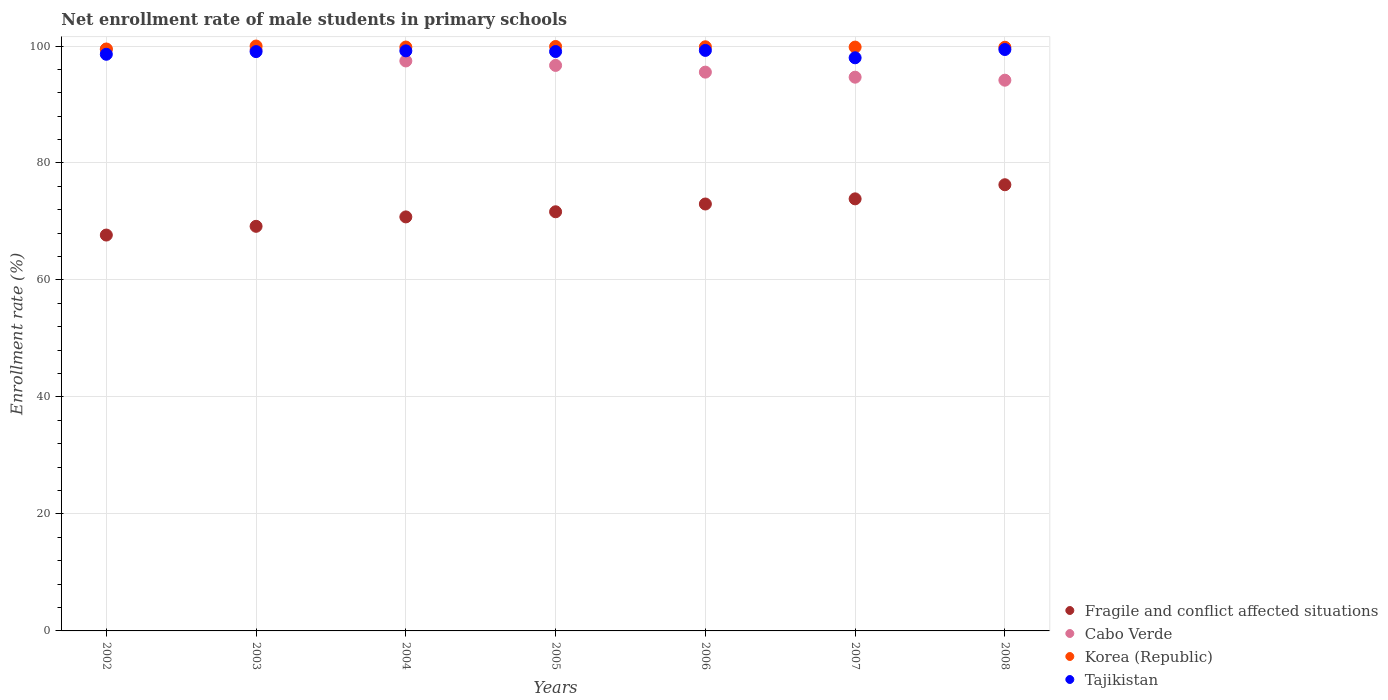How many different coloured dotlines are there?
Offer a very short reply. 4. Is the number of dotlines equal to the number of legend labels?
Your answer should be compact. Yes. What is the net enrollment rate of male students in primary schools in Korea (Republic) in 2008?
Provide a succinct answer. 99.78. Across all years, what is the maximum net enrollment rate of male students in primary schools in Cabo Verde?
Offer a terse response. 99.43. Across all years, what is the minimum net enrollment rate of male students in primary schools in Korea (Republic)?
Your answer should be very brief. 99.49. What is the total net enrollment rate of male students in primary schools in Fragile and conflict affected situations in the graph?
Your answer should be compact. 502.43. What is the difference between the net enrollment rate of male students in primary schools in Tajikistan in 2003 and that in 2005?
Keep it short and to the point. -0.01. What is the difference between the net enrollment rate of male students in primary schools in Korea (Republic) in 2008 and the net enrollment rate of male students in primary schools in Cabo Verde in 2007?
Keep it short and to the point. 5.11. What is the average net enrollment rate of male students in primary schools in Fragile and conflict affected situations per year?
Keep it short and to the point. 71.78. In the year 2005, what is the difference between the net enrollment rate of male students in primary schools in Korea (Republic) and net enrollment rate of male students in primary schools in Cabo Verde?
Your answer should be very brief. 3.24. In how many years, is the net enrollment rate of male students in primary schools in Korea (Republic) greater than 84 %?
Give a very brief answer. 7. What is the ratio of the net enrollment rate of male students in primary schools in Fragile and conflict affected situations in 2003 to that in 2005?
Offer a very short reply. 0.97. Is the difference between the net enrollment rate of male students in primary schools in Korea (Republic) in 2002 and 2006 greater than the difference between the net enrollment rate of male students in primary schools in Cabo Verde in 2002 and 2006?
Your answer should be compact. No. What is the difference between the highest and the second highest net enrollment rate of male students in primary schools in Fragile and conflict affected situations?
Your response must be concise. 2.41. What is the difference between the highest and the lowest net enrollment rate of male students in primary schools in Tajikistan?
Your answer should be very brief. 1.41. In how many years, is the net enrollment rate of male students in primary schools in Tajikistan greater than the average net enrollment rate of male students in primary schools in Tajikistan taken over all years?
Offer a terse response. 5. Is the sum of the net enrollment rate of male students in primary schools in Tajikistan in 2005 and 2006 greater than the maximum net enrollment rate of male students in primary schools in Korea (Republic) across all years?
Your answer should be very brief. Yes. Is it the case that in every year, the sum of the net enrollment rate of male students in primary schools in Cabo Verde and net enrollment rate of male students in primary schools in Korea (Republic)  is greater than the sum of net enrollment rate of male students in primary schools in Tajikistan and net enrollment rate of male students in primary schools in Fragile and conflict affected situations?
Ensure brevity in your answer.  No. Is the net enrollment rate of male students in primary schools in Fragile and conflict affected situations strictly greater than the net enrollment rate of male students in primary schools in Korea (Republic) over the years?
Provide a succinct answer. No. Is the net enrollment rate of male students in primary schools in Fragile and conflict affected situations strictly less than the net enrollment rate of male students in primary schools in Cabo Verde over the years?
Your response must be concise. Yes. How many dotlines are there?
Make the answer very short. 4. What is the difference between two consecutive major ticks on the Y-axis?
Give a very brief answer. 20. Are the values on the major ticks of Y-axis written in scientific E-notation?
Offer a very short reply. No. Does the graph contain grids?
Your answer should be compact. Yes. Where does the legend appear in the graph?
Provide a short and direct response. Bottom right. How many legend labels are there?
Offer a very short reply. 4. How are the legend labels stacked?
Keep it short and to the point. Vertical. What is the title of the graph?
Your answer should be compact. Net enrollment rate of male students in primary schools. Does "India" appear as one of the legend labels in the graph?
Offer a terse response. No. What is the label or title of the Y-axis?
Offer a very short reply. Enrollment rate (%). What is the Enrollment rate (%) of Fragile and conflict affected situations in 2002?
Offer a very short reply. 67.68. What is the Enrollment rate (%) of Cabo Verde in 2002?
Give a very brief answer. 99.43. What is the Enrollment rate (%) of Korea (Republic) in 2002?
Your response must be concise. 99.49. What is the Enrollment rate (%) of Tajikistan in 2002?
Ensure brevity in your answer.  98.59. What is the Enrollment rate (%) in Fragile and conflict affected situations in 2003?
Your answer should be very brief. 69.17. What is the Enrollment rate (%) of Cabo Verde in 2003?
Provide a succinct answer. 99.38. What is the Enrollment rate (%) of Korea (Republic) in 2003?
Provide a succinct answer. 100. What is the Enrollment rate (%) in Tajikistan in 2003?
Ensure brevity in your answer.  99.04. What is the Enrollment rate (%) in Fragile and conflict affected situations in 2004?
Your answer should be very brief. 70.78. What is the Enrollment rate (%) in Cabo Verde in 2004?
Keep it short and to the point. 97.44. What is the Enrollment rate (%) in Korea (Republic) in 2004?
Offer a very short reply. 99.82. What is the Enrollment rate (%) of Tajikistan in 2004?
Your answer should be very brief. 99.17. What is the Enrollment rate (%) in Fragile and conflict affected situations in 2005?
Offer a very short reply. 71.66. What is the Enrollment rate (%) of Cabo Verde in 2005?
Provide a short and direct response. 96.68. What is the Enrollment rate (%) of Korea (Republic) in 2005?
Make the answer very short. 99.92. What is the Enrollment rate (%) of Tajikistan in 2005?
Your response must be concise. 99.05. What is the Enrollment rate (%) of Fragile and conflict affected situations in 2006?
Offer a terse response. 72.99. What is the Enrollment rate (%) of Cabo Verde in 2006?
Your answer should be very brief. 95.53. What is the Enrollment rate (%) of Korea (Republic) in 2006?
Ensure brevity in your answer.  99.87. What is the Enrollment rate (%) in Tajikistan in 2006?
Make the answer very short. 99.25. What is the Enrollment rate (%) of Fragile and conflict affected situations in 2007?
Your response must be concise. 73.87. What is the Enrollment rate (%) in Cabo Verde in 2007?
Your answer should be very brief. 94.67. What is the Enrollment rate (%) in Korea (Republic) in 2007?
Offer a very short reply. 99.81. What is the Enrollment rate (%) of Tajikistan in 2007?
Give a very brief answer. 97.99. What is the Enrollment rate (%) of Fragile and conflict affected situations in 2008?
Provide a short and direct response. 76.28. What is the Enrollment rate (%) in Cabo Verde in 2008?
Your answer should be very brief. 94.15. What is the Enrollment rate (%) of Korea (Republic) in 2008?
Make the answer very short. 99.78. What is the Enrollment rate (%) of Tajikistan in 2008?
Your answer should be compact. 99.4. Across all years, what is the maximum Enrollment rate (%) of Fragile and conflict affected situations?
Your answer should be compact. 76.28. Across all years, what is the maximum Enrollment rate (%) in Cabo Verde?
Give a very brief answer. 99.43. Across all years, what is the maximum Enrollment rate (%) of Korea (Republic)?
Keep it short and to the point. 100. Across all years, what is the maximum Enrollment rate (%) in Tajikistan?
Provide a short and direct response. 99.4. Across all years, what is the minimum Enrollment rate (%) of Fragile and conflict affected situations?
Keep it short and to the point. 67.68. Across all years, what is the minimum Enrollment rate (%) of Cabo Verde?
Your response must be concise. 94.15. Across all years, what is the minimum Enrollment rate (%) of Korea (Republic)?
Your answer should be very brief. 99.49. Across all years, what is the minimum Enrollment rate (%) in Tajikistan?
Provide a succinct answer. 97.99. What is the total Enrollment rate (%) of Fragile and conflict affected situations in the graph?
Ensure brevity in your answer.  502.43. What is the total Enrollment rate (%) of Cabo Verde in the graph?
Keep it short and to the point. 677.29. What is the total Enrollment rate (%) of Korea (Republic) in the graph?
Your response must be concise. 698.69. What is the total Enrollment rate (%) in Tajikistan in the graph?
Make the answer very short. 692.49. What is the difference between the Enrollment rate (%) in Fragile and conflict affected situations in 2002 and that in 2003?
Ensure brevity in your answer.  -1.49. What is the difference between the Enrollment rate (%) in Cabo Verde in 2002 and that in 2003?
Provide a short and direct response. 0.06. What is the difference between the Enrollment rate (%) of Korea (Republic) in 2002 and that in 2003?
Provide a short and direct response. -0.51. What is the difference between the Enrollment rate (%) in Tajikistan in 2002 and that in 2003?
Ensure brevity in your answer.  -0.46. What is the difference between the Enrollment rate (%) of Fragile and conflict affected situations in 2002 and that in 2004?
Provide a short and direct response. -3.1. What is the difference between the Enrollment rate (%) in Cabo Verde in 2002 and that in 2004?
Offer a very short reply. 1.99. What is the difference between the Enrollment rate (%) of Korea (Republic) in 2002 and that in 2004?
Your response must be concise. -0.33. What is the difference between the Enrollment rate (%) of Tajikistan in 2002 and that in 2004?
Make the answer very short. -0.58. What is the difference between the Enrollment rate (%) of Fragile and conflict affected situations in 2002 and that in 2005?
Offer a very short reply. -3.98. What is the difference between the Enrollment rate (%) of Cabo Verde in 2002 and that in 2005?
Your response must be concise. 2.75. What is the difference between the Enrollment rate (%) of Korea (Republic) in 2002 and that in 2005?
Your response must be concise. -0.43. What is the difference between the Enrollment rate (%) in Tajikistan in 2002 and that in 2005?
Make the answer very short. -0.47. What is the difference between the Enrollment rate (%) of Fragile and conflict affected situations in 2002 and that in 2006?
Make the answer very short. -5.31. What is the difference between the Enrollment rate (%) in Cabo Verde in 2002 and that in 2006?
Provide a short and direct response. 3.9. What is the difference between the Enrollment rate (%) of Korea (Republic) in 2002 and that in 2006?
Your response must be concise. -0.38. What is the difference between the Enrollment rate (%) in Tajikistan in 2002 and that in 2006?
Your response must be concise. -0.66. What is the difference between the Enrollment rate (%) in Fragile and conflict affected situations in 2002 and that in 2007?
Your answer should be very brief. -6.19. What is the difference between the Enrollment rate (%) of Cabo Verde in 2002 and that in 2007?
Provide a succinct answer. 4.76. What is the difference between the Enrollment rate (%) in Korea (Republic) in 2002 and that in 2007?
Your answer should be compact. -0.32. What is the difference between the Enrollment rate (%) of Tajikistan in 2002 and that in 2007?
Offer a terse response. 0.6. What is the difference between the Enrollment rate (%) in Fragile and conflict affected situations in 2002 and that in 2008?
Provide a short and direct response. -8.6. What is the difference between the Enrollment rate (%) of Cabo Verde in 2002 and that in 2008?
Offer a terse response. 5.28. What is the difference between the Enrollment rate (%) in Korea (Republic) in 2002 and that in 2008?
Ensure brevity in your answer.  -0.3. What is the difference between the Enrollment rate (%) of Tajikistan in 2002 and that in 2008?
Offer a terse response. -0.81. What is the difference between the Enrollment rate (%) of Fragile and conflict affected situations in 2003 and that in 2004?
Offer a terse response. -1.61. What is the difference between the Enrollment rate (%) of Cabo Verde in 2003 and that in 2004?
Provide a succinct answer. 1.93. What is the difference between the Enrollment rate (%) of Korea (Republic) in 2003 and that in 2004?
Provide a succinct answer. 0.18. What is the difference between the Enrollment rate (%) of Tajikistan in 2003 and that in 2004?
Provide a succinct answer. -0.13. What is the difference between the Enrollment rate (%) of Fragile and conflict affected situations in 2003 and that in 2005?
Provide a succinct answer. -2.49. What is the difference between the Enrollment rate (%) of Cabo Verde in 2003 and that in 2005?
Your response must be concise. 2.69. What is the difference between the Enrollment rate (%) of Korea (Republic) in 2003 and that in 2005?
Make the answer very short. 0.08. What is the difference between the Enrollment rate (%) of Tajikistan in 2003 and that in 2005?
Make the answer very short. -0.01. What is the difference between the Enrollment rate (%) of Fragile and conflict affected situations in 2003 and that in 2006?
Provide a succinct answer. -3.81. What is the difference between the Enrollment rate (%) of Cabo Verde in 2003 and that in 2006?
Your response must be concise. 3.84. What is the difference between the Enrollment rate (%) in Korea (Republic) in 2003 and that in 2006?
Your response must be concise. 0.13. What is the difference between the Enrollment rate (%) of Tajikistan in 2003 and that in 2006?
Your response must be concise. -0.21. What is the difference between the Enrollment rate (%) of Fragile and conflict affected situations in 2003 and that in 2007?
Ensure brevity in your answer.  -4.69. What is the difference between the Enrollment rate (%) in Cabo Verde in 2003 and that in 2007?
Keep it short and to the point. 4.71. What is the difference between the Enrollment rate (%) in Korea (Republic) in 2003 and that in 2007?
Your answer should be very brief. 0.18. What is the difference between the Enrollment rate (%) in Tajikistan in 2003 and that in 2007?
Keep it short and to the point. 1.06. What is the difference between the Enrollment rate (%) of Fragile and conflict affected situations in 2003 and that in 2008?
Offer a terse response. -7.11. What is the difference between the Enrollment rate (%) in Cabo Verde in 2003 and that in 2008?
Keep it short and to the point. 5.22. What is the difference between the Enrollment rate (%) of Korea (Republic) in 2003 and that in 2008?
Offer a very short reply. 0.21. What is the difference between the Enrollment rate (%) of Tajikistan in 2003 and that in 2008?
Offer a terse response. -0.36. What is the difference between the Enrollment rate (%) in Fragile and conflict affected situations in 2004 and that in 2005?
Your answer should be compact. -0.88. What is the difference between the Enrollment rate (%) of Cabo Verde in 2004 and that in 2005?
Make the answer very short. 0.76. What is the difference between the Enrollment rate (%) of Korea (Republic) in 2004 and that in 2005?
Your response must be concise. -0.1. What is the difference between the Enrollment rate (%) in Tajikistan in 2004 and that in 2005?
Keep it short and to the point. 0.12. What is the difference between the Enrollment rate (%) in Fragile and conflict affected situations in 2004 and that in 2006?
Offer a very short reply. -2.21. What is the difference between the Enrollment rate (%) of Cabo Verde in 2004 and that in 2006?
Provide a short and direct response. 1.91. What is the difference between the Enrollment rate (%) of Korea (Republic) in 2004 and that in 2006?
Ensure brevity in your answer.  -0.05. What is the difference between the Enrollment rate (%) of Tajikistan in 2004 and that in 2006?
Ensure brevity in your answer.  -0.08. What is the difference between the Enrollment rate (%) in Fragile and conflict affected situations in 2004 and that in 2007?
Your response must be concise. -3.09. What is the difference between the Enrollment rate (%) in Cabo Verde in 2004 and that in 2007?
Provide a short and direct response. 2.77. What is the difference between the Enrollment rate (%) in Korea (Republic) in 2004 and that in 2007?
Give a very brief answer. 0.01. What is the difference between the Enrollment rate (%) of Tajikistan in 2004 and that in 2007?
Offer a terse response. 1.19. What is the difference between the Enrollment rate (%) of Fragile and conflict affected situations in 2004 and that in 2008?
Provide a succinct answer. -5.5. What is the difference between the Enrollment rate (%) in Cabo Verde in 2004 and that in 2008?
Keep it short and to the point. 3.29. What is the difference between the Enrollment rate (%) in Korea (Republic) in 2004 and that in 2008?
Your response must be concise. 0.04. What is the difference between the Enrollment rate (%) of Tajikistan in 2004 and that in 2008?
Make the answer very short. -0.23. What is the difference between the Enrollment rate (%) in Fragile and conflict affected situations in 2005 and that in 2006?
Your response must be concise. -1.33. What is the difference between the Enrollment rate (%) of Cabo Verde in 2005 and that in 2006?
Provide a succinct answer. 1.15. What is the difference between the Enrollment rate (%) in Korea (Republic) in 2005 and that in 2006?
Offer a terse response. 0.05. What is the difference between the Enrollment rate (%) of Tajikistan in 2005 and that in 2006?
Your response must be concise. -0.19. What is the difference between the Enrollment rate (%) of Fragile and conflict affected situations in 2005 and that in 2007?
Your response must be concise. -2.21. What is the difference between the Enrollment rate (%) of Cabo Verde in 2005 and that in 2007?
Ensure brevity in your answer.  2.01. What is the difference between the Enrollment rate (%) in Korea (Republic) in 2005 and that in 2007?
Give a very brief answer. 0.11. What is the difference between the Enrollment rate (%) in Tajikistan in 2005 and that in 2007?
Offer a terse response. 1.07. What is the difference between the Enrollment rate (%) of Fragile and conflict affected situations in 2005 and that in 2008?
Give a very brief answer. -4.62. What is the difference between the Enrollment rate (%) in Cabo Verde in 2005 and that in 2008?
Offer a very short reply. 2.53. What is the difference between the Enrollment rate (%) of Korea (Republic) in 2005 and that in 2008?
Ensure brevity in your answer.  0.13. What is the difference between the Enrollment rate (%) in Tajikistan in 2005 and that in 2008?
Your answer should be very brief. -0.35. What is the difference between the Enrollment rate (%) in Fragile and conflict affected situations in 2006 and that in 2007?
Make the answer very short. -0.88. What is the difference between the Enrollment rate (%) of Cabo Verde in 2006 and that in 2007?
Provide a succinct answer. 0.86. What is the difference between the Enrollment rate (%) in Korea (Republic) in 2006 and that in 2007?
Provide a short and direct response. 0.05. What is the difference between the Enrollment rate (%) in Tajikistan in 2006 and that in 2007?
Give a very brief answer. 1.26. What is the difference between the Enrollment rate (%) in Fragile and conflict affected situations in 2006 and that in 2008?
Keep it short and to the point. -3.29. What is the difference between the Enrollment rate (%) of Cabo Verde in 2006 and that in 2008?
Your answer should be compact. 1.38. What is the difference between the Enrollment rate (%) of Korea (Republic) in 2006 and that in 2008?
Provide a succinct answer. 0.08. What is the difference between the Enrollment rate (%) of Tajikistan in 2006 and that in 2008?
Give a very brief answer. -0.15. What is the difference between the Enrollment rate (%) in Fragile and conflict affected situations in 2007 and that in 2008?
Your response must be concise. -2.41. What is the difference between the Enrollment rate (%) in Cabo Verde in 2007 and that in 2008?
Offer a very short reply. 0.52. What is the difference between the Enrollment rate (%) in Korea (Republic) in 2007 and that in 2008?
Keep it short and to the point. 0.03. What is the difference between the Enrollment rate (%) in Tajikistan in 2007 and that in 2008?
Keep it short and to the point. -1.41. What is the difference between the Enrollment rate (%) in Fragile and conflict affected situations in 2002 and the Enrollment rate (%) in Cabo Verde in 2003?
Ensure brevity in your answer.  -31.7. What is the difference between the Enrollment rate (%) in Fragile and conflict affected situations in 2002 and the Enrollment rate (%) in Korea (Republic) in 2003?
Your answer should be very brief. -32.32. What is the difference between the Enrollment rate (%) in Fragile and conflict affected situations in 2002 and the Enrollment rate (%) in Tajikistan in 2003?
Keep it short and to the point. -31.36. What is the difference between the Enrollment rate (%) in Cabo Verde in 2002 and the Enrollment rate (%) in Korea (Republic) in 2003?
Your answer should be very brief. -0.56. What is the difference between the Enrollment rate (%) in Cabo Verde in 2002 and the Enrollment rate (%) in Tajikistan in 2003?
Provide a succinct answer. 0.39. What is the difference between the Enrollment rate (%) in Korea (Republic) in 2002 and the Enrollment rate (%) in Tajikistan in 2003?
Offer a terse response. 0.45. What is the difference between the Enrollment rate (%) in Fragile and conflict affected situations in 2002 and the Enrollment rate (%) in Cabo Verde in 2004?
Make the answer very short. -29.76. What is the difference between the Enrollment rate (%) in Fragile and conflict affected situations in 2002 and the Enrollment rate (%) in Korea (Republic) in 2004?
Provide a succinct answer. -32.14. What is the difference between the Enrollment rate (%) in Fragile and conflict affected situations in 2002 and the Enrollment rate (%) in Tajikistan in 2004?
Your response must be concise. -31.49. What is the difference between the Enrollment rate (%) in Cabo Verde in 2002 and the Enrollment rate (%) in Korea (Republic) in 2004?
Your response must be concise. -0.39. What is the difference between the Enrollment rate (%) of Cabo Verde in 2002 and the Enrollment rate (%) of Tajikistan in 2004?
Your answer should be compact. 0.26. What is the difference between the Enrollment rate (%) of Korea (Republic) in 2002 and the Enrollment rate (%) of Tajikistan in 2004?
Offer a terse response. 0.32. What is the difference between the Enrollment rate (%) of Fragile and conflict affected situations in 2002 and the Enrollment rate (%) of Cabo Verde in 2005?
Offer a terse response. -29. What is the difference between the Enrollment rate (%) in Fragile and conflict affected situations in 2002 and the Enrollment rate (%) in Korea (Republic) in 2005?
Ensure brevity in your answer.  -32.24. What is the difference between the Enrollment rate (%) in Fragile and conflict affected situations in 2002 and the Enrollment rate (%) in Tajikistan in 2005?
Offer a very short reply. -31.37. What is the difference between the Enrollment rate (%) of Cabo Verde in 2002 and the Enrollment rate (%) of Korea (Republic) in 2005?
Provide a short and direct response. -0.48. What is the difference between the Enrollment rate (%) of Cabo Verde in 2002 and the Enrollment rate (%) of Tajikistan in 2005?
Provide a succinct answer. 0.38. What is the difference between the Enrollment rate (%) of Korea (Republic) in 2002 and the Enrollment rate (%) of Tajikistan in 2005?
Give a very brief answer. 0.43. What is the difference between the Enrollment rate (%) of Fragile and conflict affected situations in 2002 and the Enrollment rate (%) of Cabo Verde in 2006?
Your answer should be very brief. -27.85. What is the difference between the Enrollment rate (%) in Fragile and conflict affected situations in 2002 and the Enrollment rate (%) in Korea (Republic) in 2006?
Provide a succinct answer. -32.19. What is the difference between the Enrollment rate (%) of Fragile and conflict affected situations in 2002 and the Enrollment rate (%) of Tajikistan in 2006?
Provide a succinct answer. -31.57. What is the difference between the Enrollment rate (%) in Cabo Verde in 2002 and the Enrollment rate (%) in Korea (Republic) in 2006?
Ensure brevity in your answer.  -0.43. What is the difference between the Enrollment rate (%) in Cabo Verde in 2002 and the Enrollment rate (%) in Tajikistan in 2006?
Your answer should be compact. 0.19. What is the difference between the Enrollment rate (%) of Korea (Republic) in 2002 and the Enrollment rate (%) of Tajikistan in 2006?
Provide a short and direct response. 0.24. What is the difference between the Enrollment rate (%) of Fragile and conflict affected situations in 2002 and the Enrollment rate (%) of Cabo Verde in 2007?
Offer a very short reply. -26.99. What is the difference between the Enrollment rate (%) in Fragile and conflict affected situations in 2002 and the Enrollment rate (%) in Korea (Republic) in 2007?
Ensure brevity in your answer.  -32.13. What is the difference between the Enrollment rate (%) of Fragile and conflict affected situations in 2002 and the Enrollment rate (%) of Tajikistan in 2007?
Provide a short and direct response. -30.31. What is the difference between the Enrollment rate (%) of Cabo Verde in 2002 and the Enrollment rate (%) of Korea (Republic) in 2007?
Your answer should be very brief. -0.38. What is the difference between the Enrollment rate (%) of Cabo Verde in 2002 and the Enrollment rate (%) of Tajikistan in 2007?
Ensure brevity in your answer.  1.45. What is the difference between the Enrollment rate (%) of Korea (Republic) in 2002 and the Enrollment rate (%) of Tajikistan in 2007?
Offer a terse response. 1.5. What is the difference between the Enrollment rate (%) of Fragile and conflict affected situations in 2002 and the Enrollment rate (%) of Cabo Verde in 2008?
Make the answer very short. -26.47. What is the difference between the Enrollment rate (%) in Fragile and conflict affected situations in 2002 and the Enrollment rate (%) in Korea (Republic) in 2008?
Offer a very short reply. -32.1. What is the difference between the Enrollment rate (%) of Fragile and conflict affected situations in 2002 and the Enrollment rate (%) of Tajikistan in 2008?
Keep it short and to the point. -31.72. What is the difference between the Enrollment rate (%) of Cabo Verde in 2002 and the Enrollment rate (%) of Korea (Republic) in 2008?
Your answer should be very brief. -0.35. What is the difference between the Enrollment rate (%) in Cabo Verde in 2002 and the Enrollment rate (%) in Tajikistan in 2008?
Provide a short and direct response. 0.03. What is the difference between the Enrollment rate (%) of Korea (Republic) in 2002 and the Enrollment rate (%) of Tajikistan in 2008?
Ensure brevity in your answer.  0.09. What is the difference between the Enrollment rate (%) of Fragile and conflict affected situations in 2003 and the Enrollment rate (%) of Cabo Verde in 2004?
Offer a very short reply. -28.27. What is the difference between the Enrollment rate (%) in Fragile and conflict affected situations in 2003 and the Enrollment rate (%) in Korea (Republic) in 2004?
Your answer should be compact. -30.65. What is the difference between the Enrollment rate (%) in Fragile and conflict affected situations in 2003 and the Enrollment rate (%) in Tajikistan in 2004?
Keep it short and to the point. -30. What is the difference between the Enrollment rate (%) in Cabo Verde in 2003 and the Enrollment rate (%) in Korea (Republic) in 2004?
Make the answer very short. -0.45. What is the difference between the Enrollment rate (%) of Cabo Verde in 2003 and the Enrollment rate (%) of Tajikistan in 2004?
Offer a very short reply. 0.2. What is the difference between the Enrollment rate (%) of Korea (Republic) in 2003 and the Enrollment rate (%) of Tajikistan in 2004?
Give a very brief answer. 0.83. What is the difference between the Enrollment rate (%) of Fragile and conflict affected situations in 2003 and the Enrollment rate (%) of Cabo Verde in 2005?
Provide a short and direct response. -27.51. What is the difference between the Enrollment rate (%) of Fragile and conflict affected situations in 2003 and the Enrollment rate (%) of Korea (Republic) in 2005?
Offer a very short reply. -30.74. What is the difference between the Enrollment rate (%) of Fragile and conflict affected situations in 2003 and the Enrollment rate (%) of Tajikistan in 2005?
Offer a very short reply. -29.88. What is the difference between the Enrollment rate (%) in Cabo Verde in 2003 and the Enrollment rate (%) in Korea (Republic) in 2005?
Your response must be concise. -0.54. What is the difference between the Enrollment rate (%) in Cabo Verde in 2003 and the Enrollment rate (%) in Tajikistan in 2005?
Offer a terse response. 0.32. What is the difference between the Enrollment rate (%) in Korea (Republic) in 2003 and the Enrollment rate (%) in Tajikistan in 2005?
Provide a short and direct response. 0.94. What is the difference between the Enrollment rate (%) of Fragile and conflict affected situations in 2003 and the Enrollment rate (%) of Cabo Verde in 2006?
Make the answer very short. -26.36. What is the difference between the Enrollment rate (%) in Fragile and conflict affected situations in 2003 and the Enrollment rate (%) in Korea (Republic) in 2006?
Your answer should be very brief. -30.69. What is the difference between the Enrollment rate (%) in Fragile and conflict affected situations in 2003 and the Enrollment rate (%) in Tajikistan in 2006?
Provide a succinct answer. -30.07. What is the difference between the Enrollment rate (%) of Cabo Verde in 2003 and the Enrollment rate (%) of Korea (Republic) in 2006?
Your answer should be compact. -0.49. What is the difference between the Enrollment rate (%) of Cabo Verde in 2003 and the Enrollment rate (%) of Tajikistan in 2006?
Offer a terse response. 0.13. What is the difference between the Enrollment rate (%) in Korea (Republic) in 2003 and the Enrollment rate (%) in Tajikistan in 2006?
Make the answer very short. 0.75. What is the difference between the Enrollment rate (%) of Fragile and conflict affected situations in 2003 and the Enrollment rate (%) of Cabo Verde in 2007?
Your response must be concise. -25.5. What is the difference between the Enrollment rate (%) of Fragile and conflict affected situations in 2003 and the Enrollment rate (%) of Korea (Republic) in 2007?
Ensure brevity in your answer.  -30.64. What is the difference between the Enrollment rate (%) of Fragile and conflict affected situations in 2003 and the Enrollment rate (%) of Tajikistan in 2007?
Offer a terse response. -28.81. What is the difference between the Enrollment rate (%) in Cabo Verde in 2003 and the Enrollment rate (%) in Korea (Republic) in 2007?
Your response must be concise. -0.44. What is the difference between the Enrollment rate (%) of Cabo Verde in 2003 and the Enrollment rate (%) of Tajikistan in 2007?
Your answer should be very brief. 1.39. What is the difference between the Enrollment rate (%) of Korea (Republic) in 2003 and the Enrollment rate (%) of Tajikistan in 2007?
Your answer should be very brief. 2.01. What is the difference between the Enrollment rate (%) of Fragile and conflict affected situations in 2003 and the Enrollment rate (%) of Cabo Verde in 2008?
Keep it short and to the point. -24.98. What is the difference between the Enrollment rate (%) of Fragile and conflict affected situations in 2003 and the Enrollment rate (%) of Korea (Republic) in 2008?
Offer a very short reply. -30.61. What is the difference between the Enrollment rate (%) in Fragile and conflict affected situations in 2003 and the Enrollment rate (%) in Tajikistan in 2008?
Your answer should be very brief. -30.23. What is the difference between the Enrollment rate (%) in Cabo Verde in 2003 and the Enrollment rate (%) in Korea (Republic) in 2008?
Your answer should be compact. -0.41. What is the difference between the Enrollment rate (%) in Cabo Verde in 2003 and the Enrollment rate (%) in Tajikistan in 2008?
Make the answer very short. -0.03. What is the difference between the Enrollment rate (%) in Korea (Republic) in 2003 and the Enrollment rate (%) in Tajikistan in 2008?
Offer a terse response. 0.6. What is the difference between the Enrollment rate (%) of Fragile and conflict affected situations in 2004 and the Enrollment rate (%) of Cabo Verde in 2005?
Your answer should be very brief. -25.9. What is the difference between the Enrollment rate (%) in Fragile and conflict affected situations in 2004 and the Enrollment rate (%) in Korea (Republic) in 2005?
Give a very brief answer. -29.14. What is the difference between the Enrollment rate (%) in Fragile and conflict affected situations in 2004 and the Enrollment rate (%) in Tajikistan in 2005?
Offer a terse response. -28.27. What is the difference between the Enrollment rate (%) in Cabo Verde in 2004 and the Enrollment rate (%) in Korea (Republic) in 2005?
Your answer should be compact. -2.47. What is the difference between the Enrollment rate (%) of Cabo Verde in 2004 and the Enrollment rate (%) of Tajikistan in 2005?
Provide a short and direct response. -1.61. What is the difference between the Enrollment rate (%) in Korea (Republic) in 2004 and the Enrollment rate (%) in Tajikistan in 2005?
Keep it short and to the point. 0.77. What is the difference between the Enrollment rate (%) of Fragile and conflict affected situations in 2004 and the Enrollment rate (%) of Cabo Verde in 2006?
Make the answer very short. -24.75. What is the difference between the Enrollment rate (%) in Fragile and conflict affected situations in 2004 and the Enrollment rate (%) in Korea (Republic) in 2006?
Offer a terse response. -29.08. What is the difference between the Enrollment rate (%) of Fragile and conflict affected situations in 2004 and the Enrollment rate (%) of Tajikistan in 2006?
Keep it short and to the point. -28.47. What is the difference between the Enrollment rate (%) in Cabo Verde in 2004 and the Enrollment rate (%) in Korea (Republic) in 2006?
Provide a short and direct response. -2.42. What is the difference between the Enrollment rate (%) of Cabo Verde in 2004 and the Enrollment rate (%) of Tajikistan in 2006?
Your response must be concise. -1.8. What is the difference between the Enrollment rate (%) of Korea (Republic) in 2004 and the Enrollment rate (%) of Tajikistan in 2006?
Your answer should be very brief. 0.57. What is the difference between the Enrollment rate (%) in Fragile and conflict affected situations in 2004 and the Enrollment rate (%) in Cabo Verde in 2007?
Your answer should be very brief. -23.89. What is the difference between the Enrollment rate (%) of Fragile and conflict affected situations in 2004 and the Enrollment rate (%) of Korea (Republic) in 2007?
Provide a succinct answer. -29.03. What is the difference between the Enrollment rate (%) in Fragile and conflict affected situations in 2004 and the Enrollment rate (%) in Tajikistan in 2007?
Your answer should be compact. -27.2. What is the difference between the Enrollment rate (%) of Cabo Verde in 2004 and the Enrollment rate (%) of Korea (Republic) in 2007?
Offer a terse response. -2.37. What is the difference between the Enrollment rate (%) in Cabo Verde in 2004 and the Enrollment rate (%) in Tajikistan in 2007?
Offer a terse response. -0.54. What is the difference between the Enrollment rate (%) in Korea (Republic) in 2004 and the Enrollment rate (%) in Tajikistan in 2007?
Provide a short and direct response. 1.83. What is the difference between the Enrollment rate (%) in Fragile and conflict affected situations in 2004 and the Enrollment rate (%) in Cabo Verde in 2008?
Provide a short and direct response. -23.37. What is the difference between the Enrollment rate (%) of Fragile and conflict affected situations in 2004 and the Enrollment rate (%) of Korea (Republic) in 2008?
Offer a very short reply. -29. What is the difference between the Enrollment rate (%) of Fragile and conflict affected situations in 2004 and the Enrollment rate (%) of Tajikistan in 2008?
Your response must be concise. -28.62. What is the difference between the Enrollment rate (%) of Cabo Verde in 2004 and the Enrollment rate (%) of Korea (Republic) in 2008?
Your response must be concise. -2.34. What is the difference between the Enrollment rate (%) of Cabo Verde in 2004 and the Enrollment rate (%) of Tajikistan in 2008?
Offer a very short reply. -1.96. What is the difference between the Enrollment rate (%) of Korea (Republic) in 2004 and the Enrollment rate (%) of Tajikistan in 2008?
Provide a short and direct response. 0.42. What is the difference between the Enrollment rate (%) of Fragile and conflict affected situations in 2005 and the Enrollment rate (%) of Cabo Verde in 2006?
Give a very brief answer. -23.87. What is the difference between the Enrollment rate (%) in Fragile and conflict affected situations in 2005 and the Enrollment rate (%) in Korea (Republic) in 2006?
Provide a succinct answer. -28.21. What is the difference between the Enrollment rate (%) in Fragile and conflict affected situations in 2005 and the Enrollment rate (%) in Tajikistan in 2006?
Provide a short and direct response. -27.59. What is the difference between the Enrollment rate (%) in Cabo Verde in 2005 and the Enrollment rate (%) in Korea (Republic) in 2006?
Ensure brevity in your answer.  -3.18. What is the difference between the Enrollment rate (%) in Cabo Verde in 2005 and the Enrollment rate (%) in Tajikistan in 2006?
Your answer should be compact. -2.57. What is the difference between the Enrollment rate (%) in Korea (Republic) in 2005 and the Enrollment rate (%) in Tajikistan in 2006?
Make the answer very short. 0.67. What is the difference between the Enrollment rate (%) in Fragile and conflict affected situations in 2005 and the Enrollment rate (%) in Cabo Verde in 2007?
Your answer should be compact. -23.01. What is the difference between the Enrollment rate (%) of Fragile and conflict affected situations in 2005 and the Enrollment rate (%) of Korea (Republic) in 2007?
Offer a very short reply. -28.15. What is the difference between the Enrollment rate (%) of Fragile and conflict affected situations in 2005 and the Enrollment rate (%) of Tajikistan in 2007?
Your answer should be very brief. -26.33. What is the difference between the Enrollment rate (%) of Cabo Verde in 2005 and the Enrollment rate (%) of Korea (Republic) in 2007?
Your answer should be compact. -3.13. What is the difference between the Enrollment rate (%) in Cabo Verde in 2005 and the Enrollment rate (%) in Tajikistan in 2007?
Keep it short and to the point. -1.3. What is the difference between the Enrollment rate (%) in Korea (Republic) in 2005 and the Enrollment rate (%) in Tajikistan in 2007?
Your answer should be compact. 1.93. What is the difference between the Enrollment rate (%) in Fragile and conflict affected situations in 2005 and the Enrollment rate (%) in Cabo Verde in 2008?
Offer a terse response. -22.49. What is the difference between the Enrollment rate (%) in Fragile and conflict affected situations in 2005 and the Enrollment rate (%) in Korea (Republic) in 2008?
Your response must be concise. -28.12. What is the difference between the Enrollment rate (%) in Fragile and conflict affected situations in 2005 and the Enrollment rate (%) in Tajikistan in 2008?
Make the answer very short. -27.74. What is the difference between the Enrollment rate (%) of Cabo Verde in 2005 and the Enrollment rate (%) of Korea (Republic) in 2008?
Your answer should be compact. -3.1. What is the difference between the Enrollment rate (%) in Cabo Verde in 2005 and the Enrollment rate (%) in Tajikistan in 2008?
Provide a succinct answer. -2.72. What is the difference between the Enrollment rate (%) in Korea (Republic) in 2005 and the Enrollment rate (%) in Tajikistan in 2008?
Provide a short and direct response. 0.52. What is the difference between the Enrollment rate (%) of Fragile and conflict affected situations in 2006 and the Enrollment rate (%) of Cabo Verde in 2007?
Provide a succinct answer. -21.68. What is the difference between the Enrollment rate (%) in Fragile and conflict affected situations in 2006 and the Enrollment rate (%) in Korea (Republic) in 2007?
Ensure brevity in your answer.  -26.82. What is the difference between the Enrollment rate (%) of Fragile and conflict affected situations in 2006 and the Enrollment rate (%) of Tajikistan in 2007?
Offer a very short reply. -25. What is the difference between the Enrollment rate (%) in Cabo Verde in 2006 and the Enrollment rate (%) in Korea (Republic) in 2007?
Your answer should be compact. -4.28. What is the difference between the Enrollment rate (%) in Cabo Verde in 2006 and the Enrollment rate (%) in Tajikistan in 2007?
Give a very brief answer. -2.45. What is the difference between the Enrollment rate (%) in Korea (Republic) in 2006 and the Enrollment rate (%) in Tajikistan in 2007?
Keep it short and to the point. 1.88. What is the difference between the Enrollment rate (%) in Fragile and conflict affected situations in 2006 and the Enrollment rate (%) in Cabo Verde in 2008?
Keep it short and to the point. -21.17. What is the difference between the Enrollment rate (%) in Fragile and conflict affected situations in 2006 and the Enrollment rate (%) in Korea (Republic) in 2008?
Provide a succinct answer. -26.8. What is the difference between the Enrollment rate (%) of Fragile and conflict affected situations in 2006 and the Enrollment rate (%) of Tajikistan in 2008?
Make the answer very short. -26.41. What is the difference between the Enrollment rate (%) in Cabo Verde in 2006 and the Enrollment rate (%) in Korea (Republic) in 2008?
Provide a short and direct response. -4.25. What is the difference between the Enrollment rate (%) of Cabo Verde in 2006 and the Enrollment rate (%) of Tajikistan in 2008?
Provide a short and direct response. -3.87. What is the difference between the Enrollment rate (%) in Korea (Republic) in 2006 and the Enrollment rate (%) in Tajikistan in 2008?
Ensure brevity in your answer.  0.47. What is the difference between the Enrollment rate (%) of Fragile and conflict affected situations in 2007 and the Enrollment rate (%) of Cabo Verde in 2008?
Offer a terse response. -20.29. What is the difference between the Enrollment rate (%) in Fragile and conflict affected situations in 2007 and the Enrollment rate (%) in Korea (Republic) in 2008?
Provide a succinct answer. -25.92. What is the difference between the Enrollment rate (%) in Fragile and conflict affected situations in 2007 and the Enrollment rate (%) in Tajikistan in 2008?
Provide a short and direct response. -25.53. What is the difference between the Enrollment rate (%) of Cabo Verde in 2007 and the Enrollment rate (%) of Korea (Republic) in 2008?
Offer a very short reply. -5.11. What is the difference between the Enrollment rate (%) of Cabo Verde in 2007 and the Enrollment rate (%) of Tajikistan in 2008?
Keep it short and to the point. -4.73. What is the difference between the Enrollment rate (%) in Korea (Republic) in 2007 and the Enrollment rate (%) in Tajikistan in 2008?
Offer a very short reply. 0.41. What is the average Enrollment rate (%) in Fragile and conflict affected situations per year?
Make the answer very short. 71.78. What is the average Enrollment rate (%) of Cabo Verde per year?
Your answer should be compact. 96.76. What is the average Enrollment rate (%) in Korea (Republic) per year?
Make the answer very short. 99.81. What is the average Enrollment rate (%) in Tajikistan per year?
Make the answer very short. 98.93. In the year 2002, what is the difference between the Enrollment rate (%) in Fragile and conflict affected situations and Enrollment rate (%) in Cabo Verde?
Provide a short and direct response. -31.75. In the year 2002, what is the difference between the Enrollment rate (%) in Fragile and conflict affected situations and Enrollment rate (%) in Korea (Republic)?
Offer a very short reply. -31.81. In the year 2002, what is the difference between the Enrollment rate (%) in Fragile and conflict affected situations and Enrollment rate (%) in Tajikistan?
Offer a very short reply. -30.91. In the year 2002, what is the difference between the Enrollment rate (%) of Cabo Verde and Enrollment rate (%) of Korea (Republic)?
Give a very brief answer. -0.05. In the year 2002, what is the difference between the Enrollment rate (%) of Cabo Verde and Enrollment rate (%) of Tajikistan?
Your answer should be compact. 0.85. In the year 2002, what is the difference between the Enrollment rate (%) in Korea (Republic) and Enrollment rate (%) in Tajikistan?
Offer a terse response. 0.9. In the year 2003, what is the difference between the Enrollment rate (%) in Fragile and conflict affected situations and Enrollment rate (%) in Cabo Verde?
Give a very brief answer. -30.2. In the year 2003, what is the difference between the Enrollment rate (%) in Fragile and conflict affected situations and Enrollment rate (%) in Korea (Republic)?
Offer a very short reply. -30.82. In the year 2003, what is the difference between the Enrollment rate (%) of Fragile and conflict affected situations and Enrollment rate (%) of Tajikistan?
Offer a very short reply. -29.87. In the year 2003, what is the difference between the Enrollment rate (%) of Cabo Verde and Enrollment rate (%) of Korea (Republic)?
Your response must be concise. -0.62. In the year 2003, what is the difference between the Enrollment rate (%) in Cabo Verde and Enrollment rate (%) in Tajikistan?
Offer a very short reply. 0.33. In the year 2003, what is the difference between the Enrollment rate (%) in Korea (Republic) and Enrollment rate (%) in Tajikistan?
Provide a short and direct response. 0.95. In the year 2004, what is the difference between the Enrollment rate (%) of Fragile and conflict affected situations and Enrollment rate (%) of Cabo Verde?
Ensure brevity in your answer.  -26.66. In the year 2004, what is the difference between the Enrollment rate (%) of Fragile and conflict affected situations and Enrollment rate (%) of Korea (Republic)?
Provide a succinct answer. -29.04. In the year 2004, what is the difference between the Enrollment rate (%) of Fragile and conflict affected situations and Enrollment rate (%) of Tajikistan?
Your answer should be compact. -28.39. In the year 2004, what is the difference between the Enrollment rate (%) in Cabo Verde and Enrollment rate (%) in Korea (Republic)?
Ensure brevity in your answer.  -2.38. In the year 2004, what is the difference between the Enrollment rate (%) of Cabo Verde and Enrollment rate (%) of Tajikistan?
Ensure brevity in your answer.  -1.73. In the year 2004, what is the difference between the Enrollment rate (%) of Korea (Republic) and Enrollment rate (%) of Tajikistan?
Offer a very short reply. 0.65. In the year 2005, what is the difference between the Enrollment rate (%) of Fragile and conflict affected situations and Enrollment rate (%) of Cabo Verde?
Offer a terse response. -25.02. In the year 2005, what is the difference between the Enrollment rate (%) in Fragile and conflict affected situations and Enrollment rate (%) in Korea (Republic)?
Your answer should be compact. -28.26. In the year 2005, what is the difference between the Enrollment rate (%) of Fragile and conflict affected situations and Enrollment rate (%) of Tajikistan?
Provide a succinct answer. -27.39. In the year 2005, what is the difference between the Enrollment rate (%) of Cabo Verde and Enrollment rate (%) of Korea (Republic)?
Provide a succinct answer. -3.24. In the year 2005, what is the difference between the Enrollment rate (%) of Cabo Verde and Enrollment rate (%) of Tajikistan?
Make the answer very short. -2.37. In the year 2005, what is the difference between the Enrollment rate (%) of Korea (Republic) and Enrollment rate (%) of Tajikistan?
Ensure brevity in your answer.  0.86. In the year 2006, what is the difference between the Enrollment rate (%) in Fragile and conflict affected situations and Enrollment rate (%) in Cabo Verde?
Your answer should be very brief. -22.55. In the year 2006, what is the difference between the Enrollment rate (%) of Fragile and conflict affected situations and Enrollment rate (%) of Korea (Republic)?
Provide a succinct answer. -26.88. In the year 2006, what is the difference between the Enrollment rate (%) of Fragile and conflict affected situations and Enrollment rate (%) of Tajikistan?
Your response must be concise. -26.26. In the year 2006, what is the difference between the Enrollment rate (%) in Cabo Verde and Enrollment rate (%) in Korea (Republic)?
Make the answer very short. -4.33. In the year 2006, what is the difference between the Enrollment rate (%) of Cabo Verde and Enrollment rate (%) of Tajikistan?
Your answer should be very brief. -3.71. In the year 2006, what is the difference between the Enrollment rate (%) in Korea (Republic) and Enrollment rate (%) in Tajikistan?
Offer a terse response. 0.62. In the year 2007, what is the difference between the Enrollment rate (%) in Fragile and conflict affected situations and Enrollment rate (%) in Cabo Verde?
Your answer should be compact. -20.8. In the year 2007, what is the difference between the Enrollment rate (%) in Fragile and conflict affected situations and Enrollment rate (%) in Korea (Republic)?
Make the answer very short. -25.94. In the year 2007, what is the difference between the Enrollment rate (%) in Fragile and conflict affected situations and Enrollment rate (%) in Tajikistan?
Provide a short and direct response. -24.12. In the year 2007, what is the difference between the Enrollment rate (%) of Cabo Verde and Enrollment rate (%) of Korea (Republic)?
Your answer should be compact. -5.14. In the year 2007, what is the difference between the Enrollment rate (%) of Cabo Verde and Enrollment rate (%) of Tajikistan?
Your answer should be very brief. -3.32. In the year 2007, what is the difference between the Enrollment rate (%) of Korea (Republic) and Enrollment rate (%) of Tajikistan?
Give a very brief answer. 1.83. In the year 2008, what is the difference between the Enrollment rate (%) in Fragile and conflict affected situations and Enrollment rate (%) in Cabo Verde?
Make the answer very short. -17.87. In the year 2008, what is the difference between the Enrollment rate (%) in Fragile and conflict affected situations and Enrollment rate (%) in Korea (Republic)?
Your response must be concise. -23.5. In the year 2008, what is the difference between the Enrollment rate (%) in Fragile and conflict affected situations and Enrollment rate (%) in Tajikistan?
Ensure brevity in your answer.  -23.12. In the year 2008, what is the difference between the Enrollment rate (%) of Cabo Verde and Enrollment rate (%) of Korea (Republic)?
Your answer should be compact. -5.63. In the year 2008, what is the difference between the Enrollment rate (%) of Cabo Verde and Enrollment rate (%) of Tajikistan?
Provide a succinct answer. -5.25. In the year 2008, what is the difference between the Enrollment rate (%) in Korea (Republic) and Enrollment rate (%) in Tajikistan?
Make the answer very short. 0.38. What is the ratio of the Enrollment rate (%) of Fragile and conflict affected situations in 2002 to that in 2003?
Offer a terse response. 0.98. What is the ratio of the Enrollment rate (%) of Cabo Verde in 2002 to that in 2003?
Keep it short and to the point. 1. What is the ratio of the Enrollment rate (%) of Fragile and conflict affected situations in 2002 to that in 2004?
Provide a succinct answer. 0.96. What is the ratio of the Enrollment rate (%) of Cabo Verde in 2002 to that in 2004?
Provide a succinct answer. 1.02. What is the ratio of the Enrollment rate (%) in Tajikistan in 2002 to that in 2004?
Your answer should be compact. 0.99. What is the ratio of the Enrollment rate (%) in Fragile and conflict affected situations in 2002 to that in 2005?
Make the answer very short. 0.94. What is the ratio of the Enrollment rate (%) of Cabo Verde in 2002 to that in 2005?
Provide a short and direct response. 1.03. What is the ratio of the Enrollment rate (%) of Tajikistan in 2002 to that in 2005?
Offer a terse response. 1. What is the ratio of the Enrollment rate (%) of Fragile and conflict affected situations in 2002 to that in 2006?
Provide a short and direct response. 0.93. What is the ratio of the Enrollment rate (%) of Cabo Verde in 2002 to that in 2006?
Your answer should be compact. 1.04. What is the ratio of the Enrollment rate (%) of Korea (Republic) in 2002 to that in 2006?
Offer a very short reply. 1. What is the ratio of the Enrollment rate (%) in Tajikistan in 2002 to that in 2006?
Offer a terse response. 0.99. What is the ratio of the Enrollment rate (%) in Fragile and conflict affected situations in 2002 to that in 2007?
Your answer should be very brief. 0.92. What is the ratio of the Enrollment rate (%) of Cabo Verde in 2002 to that in 2007?
Make the answer very short. 1.05. What is the ratio of the Enrollment rate (%) in Korea (Republic) in 2002 to that in 2007?
Offer a very short reply. 1. What is the ratio of the Enrollment rate (%) in Fragile and conflict affected situations in 2002 to that in 2008?
Your answer should be very brief. 0.89. What is the ratio of the Enrollment rate (%) in Cabo Verde in 2002 to that in 2008?
Provide a succinct answer. 1.06. What is the ratio of the Enrollment rate (%) in Tajikistan in 2002 to that in 2008?
Offer a very short reply. 0.99. What is the ratio of the Enrollment rate (%) in Fragile and conflict affected situations in 2003 to that in 2004?
Offer a very short reply. 0.98. What is the ratio of the Enrollment rate (%) of Cabo Verde in 2003 to that in 2004?
Your response must be concise. 1.02. What is the ratio of the Enrollment rate (%) in Fragile and conflict affected situations in 2003 to that in 2005?
Provide a succinct answer. 0.97. What is the ratio of the Enrollment rate (%) of Cabo Verde in 2003 to that in 2005?
Your answer should be very brief. 1.03. What is the ratio of the Enrollment rate (%) in Tajikistan in 2003 to that in 2005?
Give a very brief answer. 1. What is the ratio of the Enrollment rate (%) in Fragile and conflict affected situations in 2003 to that in 2006?
Give a very brief answer. 0.95. What is the ratio of the Enrollment rate (%) in Cabo Verde in 2003 to that in 2006?
Provide a succinct answer. 1.04. What is the ratio of the Enrollment rate (%) of Fragile and conflict affected situations in 2003 to that in 2007?
Make the answer very short. 0.94. What is the ratio of the Enrollment rate (%) of Cabo Verde in 2003 to that in 2007?
Offer a terse response. 1.05. What is the ratio of the Enrollment rate (%) in Tajikistan in 2003 to that in 2007?
Offer a terse response. 1.01. What is the ratio of the Enrollment rate (%) of Fragile and conflict affected situations in 2003 to that in 2008?
Offer a terse response. 0.91. What is the ratio of the Enrollment rate (%) of Cabo Verde in 2003 to that in 2008?
Give a very brief answer. 1.06. What is the ratio of the Enrollment rate (%) of Tajikistan in 2003 to that in 2008?
Provide a short and direct response. 1. What is the ratio of the Enrollment rate (%) in Cabo Verde in 2004 to that in 2005?
Provide a succinct answer. 1.01. What is the ratio of the Enrollment rate (%) in Korea (Republic) in 2004 to that in 2005?
Make the answer very short. 1. What is the ratio of the Enrollment rate (%) in Fragile and conflict affected situations in 2004 to that in 2006?
Provide a succinct answer. 0.97. What is the ratio of the Enrollment rate (%) of Cabo Verde in 2004 to that in 2006?
Ensure brevity in your answer.  1.02. What is the ratio of the Enrollment rate (%) of Korea (Republic) in 2004 to that in 2006?
Give a very brief answer. 1. What is the ratio of the Enrollment rate (%) in Tajikistan in 2004 to that in 2006?
Offer a terse response. 1. What is the ratio of the Enrollment rate (%) in Fragile and conflict affected situations in 2004 to that in 2007?
Offer a very short reply. 0.96. What is the ratio of the Enrollment rate (%) in Cabo Verde in 2004 to that in 2007?
Offer a very short reply. 1.03. What is the ratio of the Enrollment rate (%) of Tajikistan in 2004 to that in 2007?
Your answer should be very brief. 1.01. What is the ratio of the Enrollment rate (%) in Fragile and conflict affected situations in 2004 to that in 2008?
Provide a succinct answer. 0.93. What is the ratio of the Enrollment rate (%) of Cabo Verde in 2004 to that in 2008?
Offer a very short reply. 1.03. What is the ratio of the Enrollment rate (%) in Korea (Republic) in 2004 to that in 2008?
Your answer should be compact. 1. What is the ratio of the Enrollment rate (%) of Fragile and conflict affected situations in 2005 to that in 2006?
Your answer should be compact. 0.98. What is the ratio of the Enrollment rate (%) of Fragile and conflict affected situations in 2005 to that in 2007?
Provide a succinct answer. 0.97. What is the ratio of the Enrollment rate (%) in Cabo Verde in 2005 to that in 2007?
Keep it short and to the point. 1.02. What is the ratio of the Enrollment rate (%) of Tajikistan in 2005 to that in 2007?
Your answer should be very brief. 1.01. What is the ratio of the Enrollment rate (%) of Fragile and conflict affected situations in 2005 to that in 2008?
Give a very brief answer. 0.94. What is the ratio of the Enrollment rate (%) of Cabo Verde in 2005 to that in 2008?
Ensure brevity in your answer.  1.03. What is the ratio of the Enrollment rate (%) in Cabo Verde in 2006 to that in 2007?
Your answer should be very brief. 1.01. What is the ratio of the Enrollment rate (%) in Tajikistan in 2006 to that in 2007?
Offer a very short reply. 1.01. What is the ratio of the Enrollment rate (%) of Fragile and conflict affected situations in 2006 to that in 2008?
Give a very brief answer. 0.96. What is the ratio of the Enrollment rate (%) of Cabo Verde in 2006 to that in 2008?
Give a very brief answer. 1.01. What is the ratio of the Enrollment rate (%) of Fragile and conflict affected situations in 2007 to that in 2008?
Your answer should be compact. 0.97. What is the ratio of the Enrollment rate (%) in Tajikistan in 2007 to that in 2008?
Offer a very short reply. 0.99. What is the difference between the highest and the second highest Enrollment rate (%) of Fragile and conflict affected situations?
Your answer should be very brief. 2.41. What is the difference between the highest and the second highest Enrollment rate (%) of Cabo Verde?
Offer a terse response. 0.06. What is the difference between the highest and the second highest Enrollment rate (%) in Korea (Republic)?
Provide a short and direct response. 0.08. What is the difference between the highest and the second highest Enrollment rate (%) in Tajikistan?
Give a very brief answer. 0.15. What is the difference between the highest and the lowest Enrollment rate (%) in Fragile and conflict affected situations?
Provide a succinct answer. 8.6. What is the difference between the highest and the lowest Enrollment rate (%) in Cabo Verde?
Make the answer very short. 5.28. What is the difference between the highest and the lowest Enrollment rate (%) of Korea (Republic)?
Your answer should be compact. 0.51. What is the difference between the highest and the lowest Enrollment rate (%) of Tajikistan?
Give a very brief answer. 1.41. 